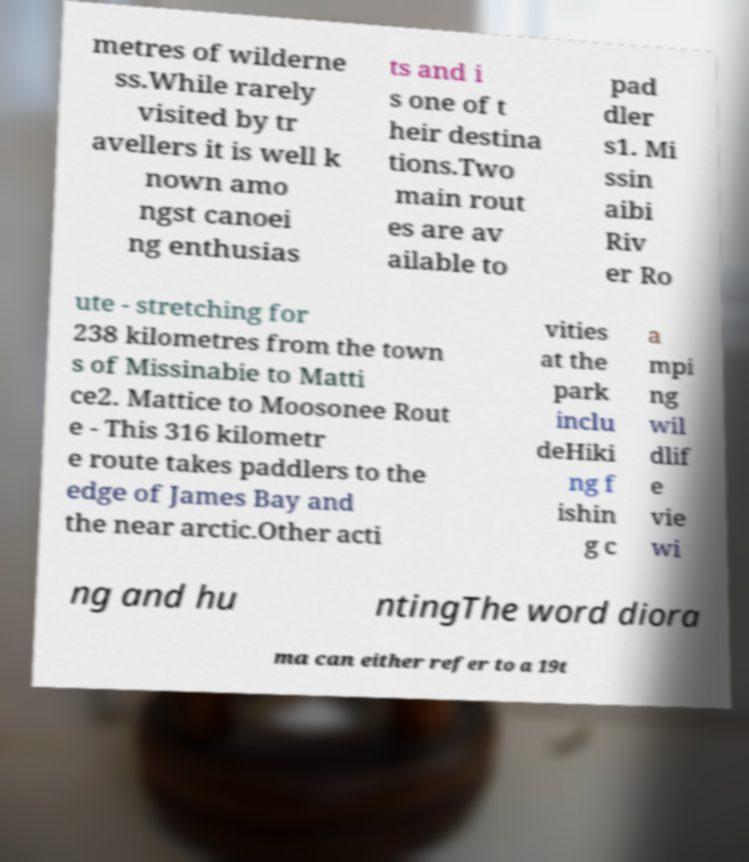Please read and relay the text visible in this image. What does it say? metres of wilderne ss.While rarely visited by tr avellers it is well k nown amo ngst canoei ng enthusias ts and i s one of t heir destina tions.Two main rout es are av ailable to pad dler s1. Mi ssin aibi Riv er Ro ute - stretching for 238 kilometres from the town s of Missinabie to Matti ce2. Mattice to Moosonee Rout e - This 316 kilometr e route takes paddlers to the edge of James Bay and the near arctic.Other acti vities at the park inclu deHiki ng f ishin g c a mpi ng wil dlif e vie wi ng and hu ntingThe word diora ma can either refer to a 19t 